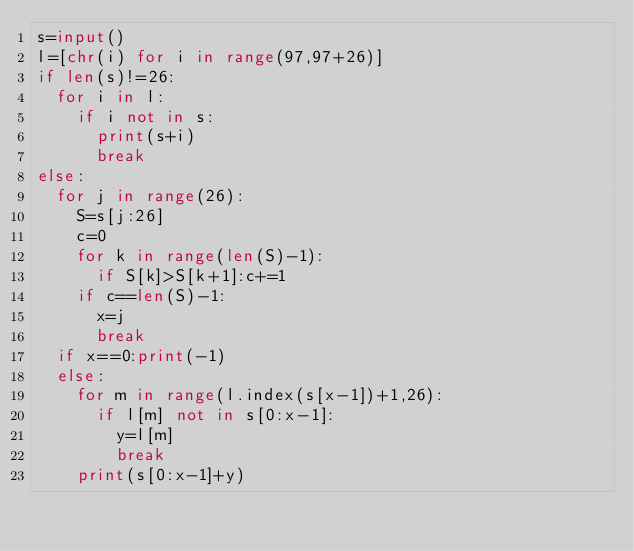Convert code to text. <code><loc_0><loc_0><loc_500><loc_500><_Python_>s=input()
l=[chr(i) for i in range(97,97+26)]
if len(s)!=26:
  for i in l:
    if i not in s:
      print(s+i)
      break
else:
  for j in range(26):
    S=s[j:26]
    c=0
    for k in range(len(S)-1):
      if S[k]>S[k+1]:c+=1
    if c==len(S)-1:
      x=j
      break
  if x==0:print(-1)
  else:
    for m in range(l.index(s[x-1])+1,26):
      if l[m] not in s[0:x-1]:
        y=l[m]
        break
    print(s[0:x-1]+y)</code> 